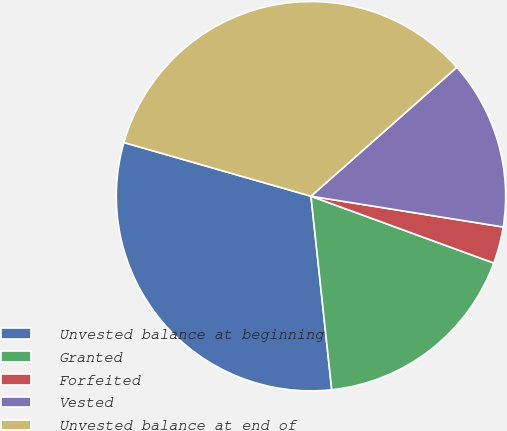Convert chart. <chart><loc_0><loc_0><loc_500><loc_500><pie_chart><fcel>Unvested balance at beginning<fcel>Granted<fcel>Forfeited<fcel>Vested<fcel>Unvested balance at end of<nl><fcel>31.15%<fcel>17.72%<fcel>3.05%<fcel>14.05%<fcel>34.03%<nl></chart> 